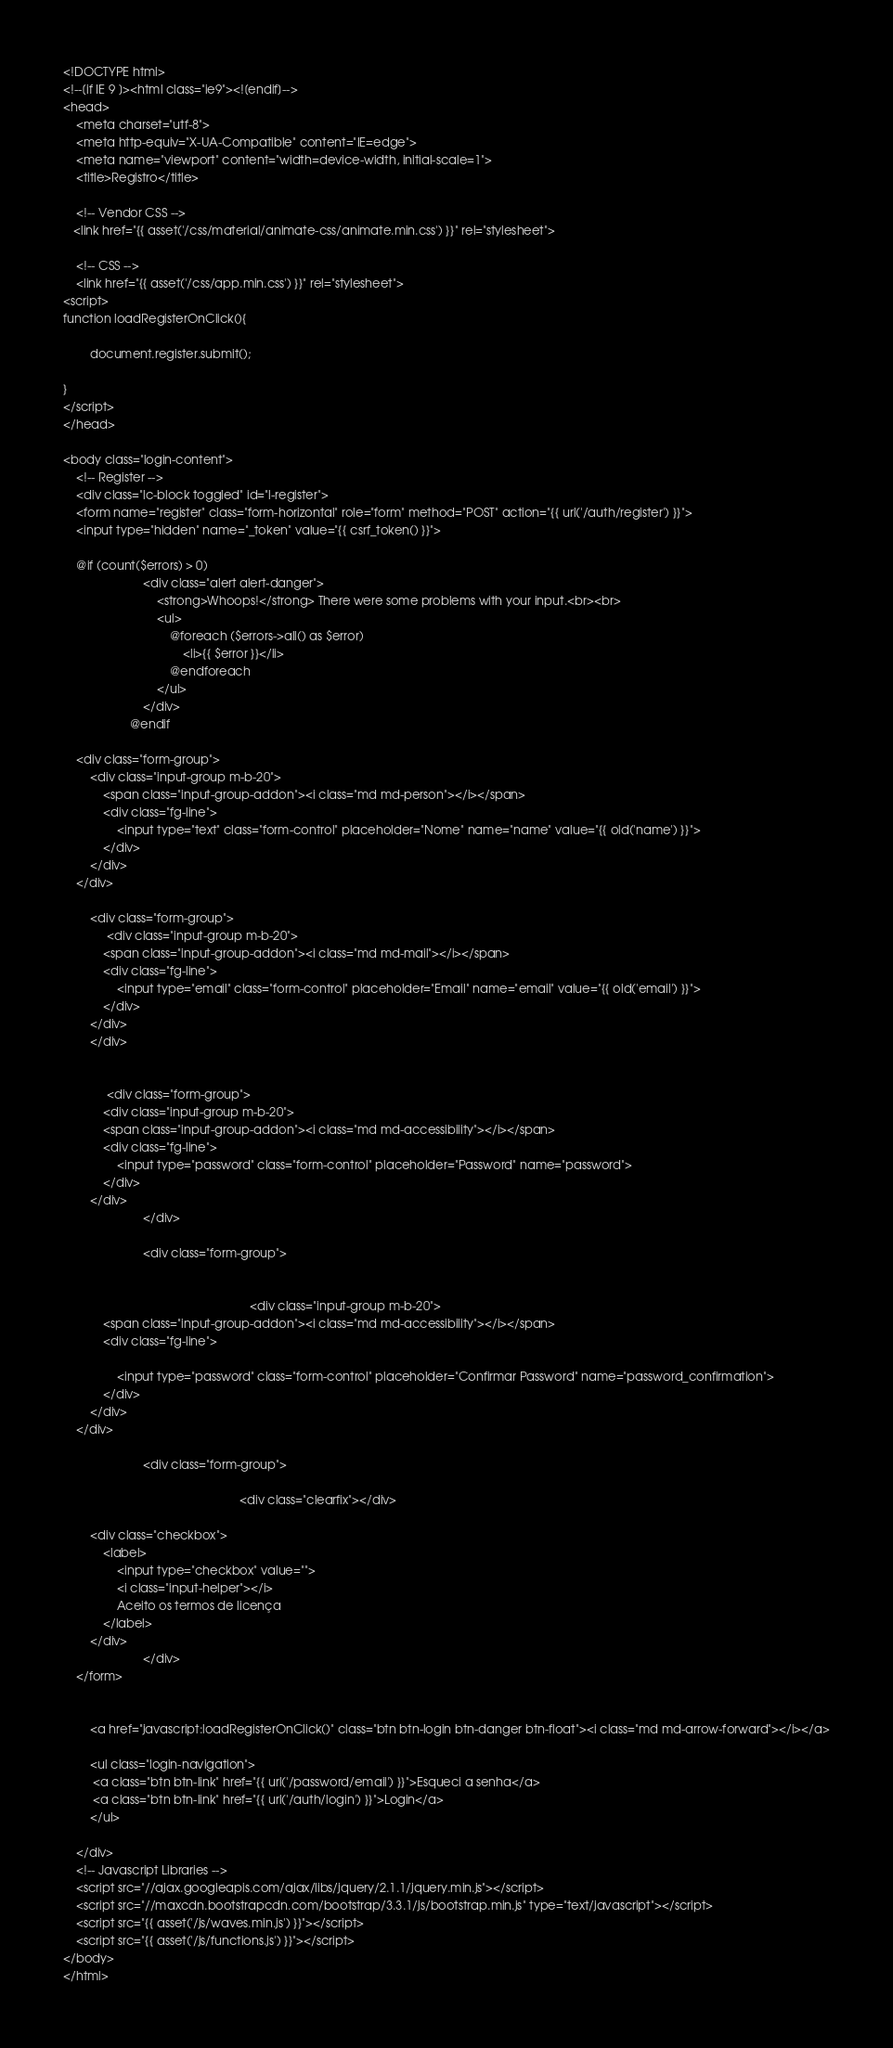<code> <loc_0><loc_0><loc_500><loc_500><_PHP_><!DOCTYPE html>
<!--[if IE 9 ]><html class="ie9"><![endif]-->
<head>
    <meta charset="utf-8">
    <meta http-equiv="X-UA-Compatible" content="IE=edge">
    <meta name="viewport" content="width=device-width, initial-scale=1">
    <title>Registro</title>

    <!-- Vendor CSS -->
   <link href="{{ asset('/css/material/animate-css/animate.min.css') }}" rel="stylesheet">

    <!-- CSS -->
    <link href="{{ asset('/css/app.min.css') }}" rel="stylesheet">
<script>
function loadRegisterOnClick(){  
 
        document.register.submit();  
      
}
</script>
</head>

<body class="login-content">
    <!-- Register -->
    <div class="lc-block toggled" id="l-register">       
    <form name="register" class="form-horizontal" role="form" method="POST" action="{{ url('/auth/register') }}">
    <input type="hidden" name="_token" value="{{ csrf_token() }}">

    @if (count($errors) > 0)
						<div class="alert alert-danger">
							<strong>Whoops!</strong> There were some problems with your input.<br><br>
							<ul>
								@foreach ($errors->all() as $error)
									<li>{{ $error }}</li>
								@endforeach
							</ul>
						</div>
					@endif
                                        
	<div class="form-group">                                                
        <div class="input-group m-b-20">
            <span class="input-group-addon"><i class="md md-person"></i></span>
            <div class="fg-line">
                <input type="text" class="form-control" placeholder="Nome" name="name" value="{{ old('name') }}">
            </div>
        </div>
	</div>

		<div class="form-group">                                                       
             <div class="input-group m-b-20">
            <span class="input-group-addon"><i class="md md-mail"></i></span>
            <div class="fg-line">
                <input type="email" class="form-control" placeholder="Email" name="email" value="{{ old('email') }}">
            </div>
        </div>
		</div>

				
             <div class="form-group">                                           
            <div class="input-group m-b-20">
            <span class="input-group-addon"><i class="md md-accessibility"></i></span>
            <div class="fg-line">
                <input type="password" class="form-control" placeholder="Password" name="password">
            </div>
        </div>
						</div>

						<div class="form-group">

                                                        
                                                        <div class="input-group m-b-20">
            <span class="input-group-addon"><i class="md md-accessibility"></i></span>
            <div class="fg-line">

                <input type="password" class="form-control" placeholder="Confirmar Password" name="password_confirmation">
            </div>
        </div>
	</div>

						<div class="form-group">
                                                    
                                                     <div class="clearfix"></div>

        <div class="checkbox">
            <label>
                <input type="checkbox" value="">
                <i class="input-helper"></i>
                Aceito os termos de licença
            </label>
        </div>
						</div>
	</form>

    
        <a href="javascript:loadRegisterOnClick()" class="btn btn-login btn-danger btn-float"><i class="md md-arrow-forward"></i></a>

        <ul class="login-navigation">        
         <a class="btn btn-link" href="{{ url('/password/email') }}">Esqueci a senha</a>
         <a class="btn btn-link" href="{{ url('/auth/login') }}">Login</a>
        </ul>
    
    </div>
    <!-- Javascript Libraries -->
    <script src="//ajax.googleapis.com/ajax/libs/jquery/2.1.1/jquery.min.js"></script>
    <script src="//maxcdn.bootstrapcdn.com/bootstrap/3.3.1/js/bootstrap.min.js" type="text/javascript"></script>
    <script src="{{ asset('/js/waves.min.js') }}"></script>
    <script src="{{ asset('/js/functions.js') }}"></script>
</body>
</html></code> 